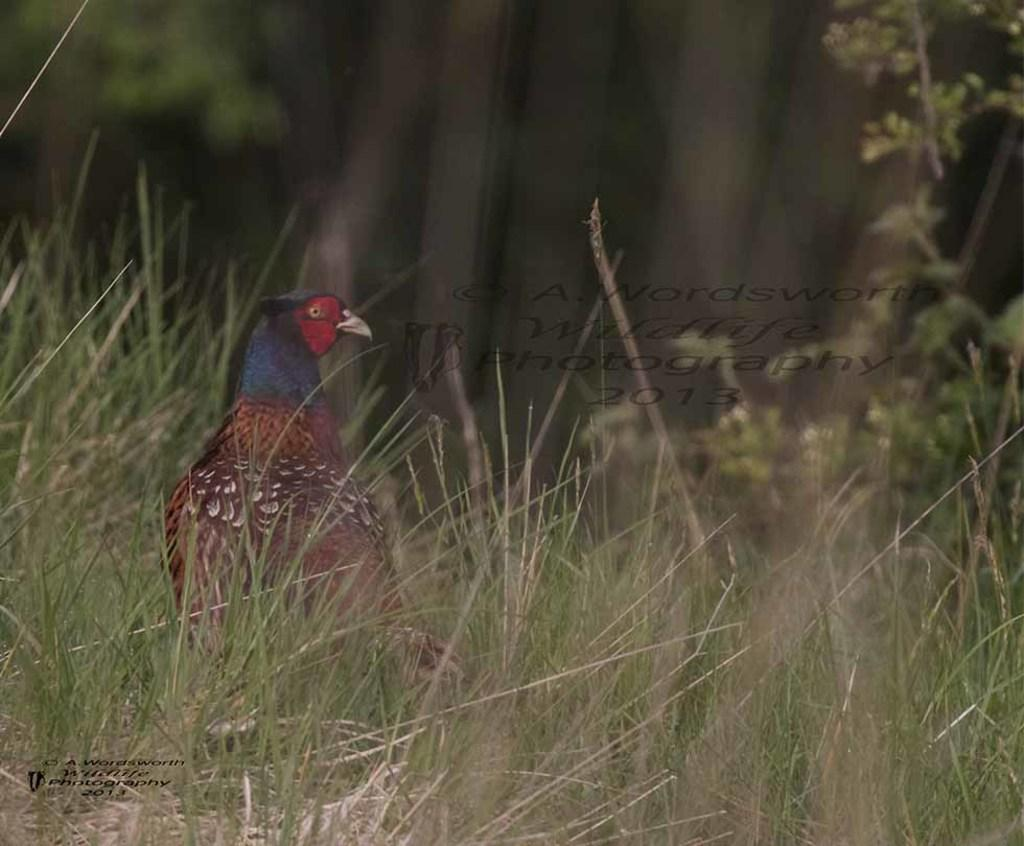What type of vegetation is visible in the image? There is grass in the image. What type of animal can be seen in the image? There is a bird in the image. What can be seen in the background of the image? There are trees in the background of the image. What hobbies does the passenger engage in while riding the bird in the image? There is no passenger present in the image, and the bird is not being ridden. 